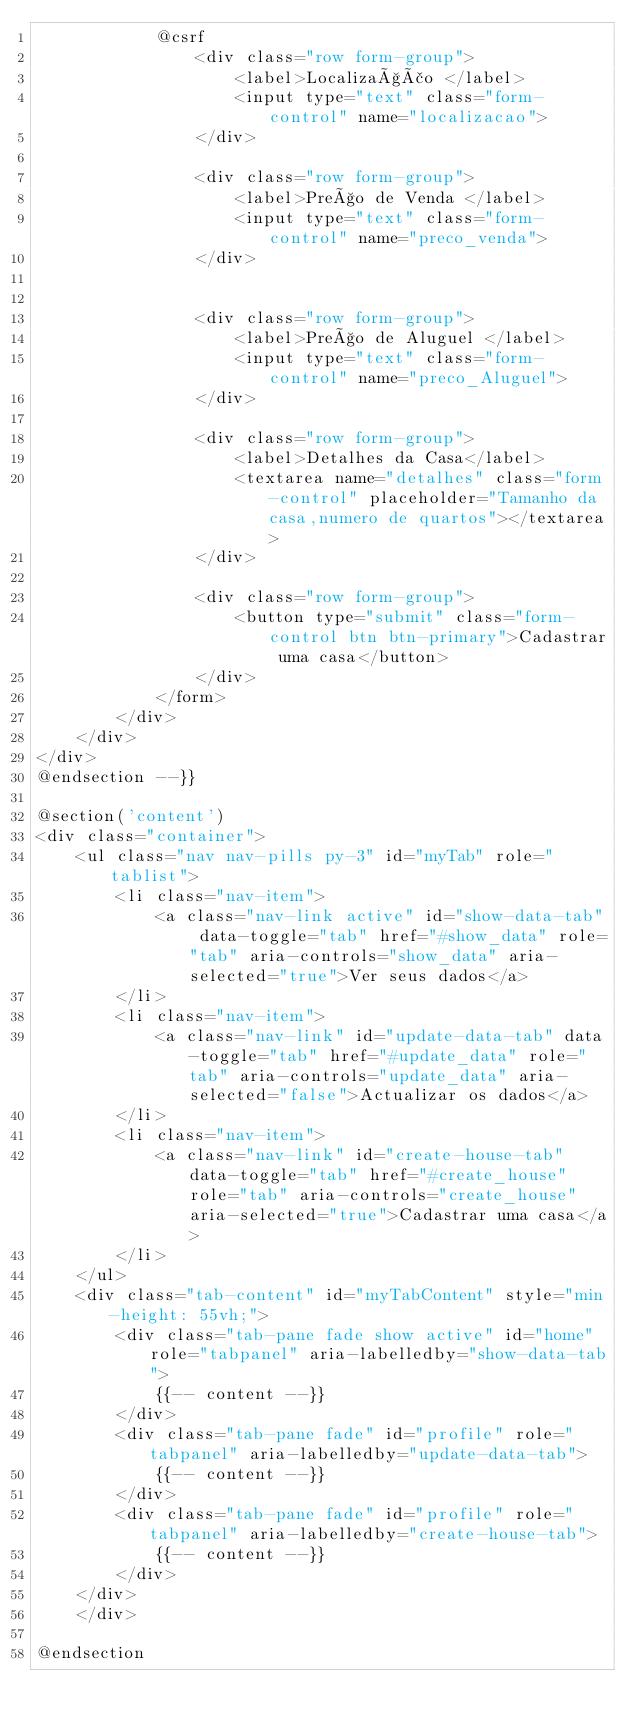Convert code to text. <code><loc_0><loc_0><loc_500><loc_500><_PHP_>            @csrf
                <div class="row form-group">
                    <label>Localização </label>
                    <input type="text" class="form-control" name="localizacao">
                </div>

                <div class="row form-group">
                    <label>Preço de Venda </label>
                    <input type="text" class="form-control" name="preco_venda">
                </div>


                <div class="row form-group">
                    <label>Preço de Aluguel </label>
                    <input type="text" class="form-control" name="preco_Aluguel">
                </div>

                <div class="row form-group">
                    <label>Detalhes da Casa</label>
                    <textarea name="detalhes" class="form-control" placeholder="Tamanho da casa,numero de quartos"></textarea>
                </div>

                <div class="row form-group">
                    <button type="submit" class="form-control btn btn-primary">Cadastrar uma casa</button>
                </div>
            </form>
        </div>
    </div>
</div>
@endsection --}}

@section('content')
<div class="container">
    <ul class="nav nav-pills py-3" id="myTab" role="tablist">
        <li class="nav-item">
            <a class="nav-link active" id="show-data-tab" data-toggle="tab" href="#show_data" role="tab" aria-controls="show_data" aria-selected="true">Ver seus dados</a>
        </li>
        <li class="nav-item">
            <a class="nav-link" id="update-data-tab" data-toggle="tab" href="#update_data" role="tab" aria-controls="update_data" aria-selected="false">Actualizar os dados</a>
        </li>
        <li class="nav-item">
            <a class="nav-link" id="create-house-tab" data-toggle="tab" href="#create_house" role="tab" aria-controls="create_house" aria-selected="true">Cadastrar uma casa</a>
        </li>
    </ul>
    <div class="tab-content" id="myTabContent" style="min-height: 55vh;">
        <div class="tab-pane fade show active" id="home" role="tabpanel" aria-labelledby="show-data-tab">
            {{-- content --}}
        </div>
        <div class="tab-pane fade" id="profile" role="tabpanel" aria-labelledby="update-data-tab">
            {{-- content --}}
        </div>
        <div class="tab-pane fade" id="profile" role="tabpanel" aria-labelledby="create-house-tab">
            {{-- content --}}
        </div>
    </div>
    </div>

@endsection
</code> 